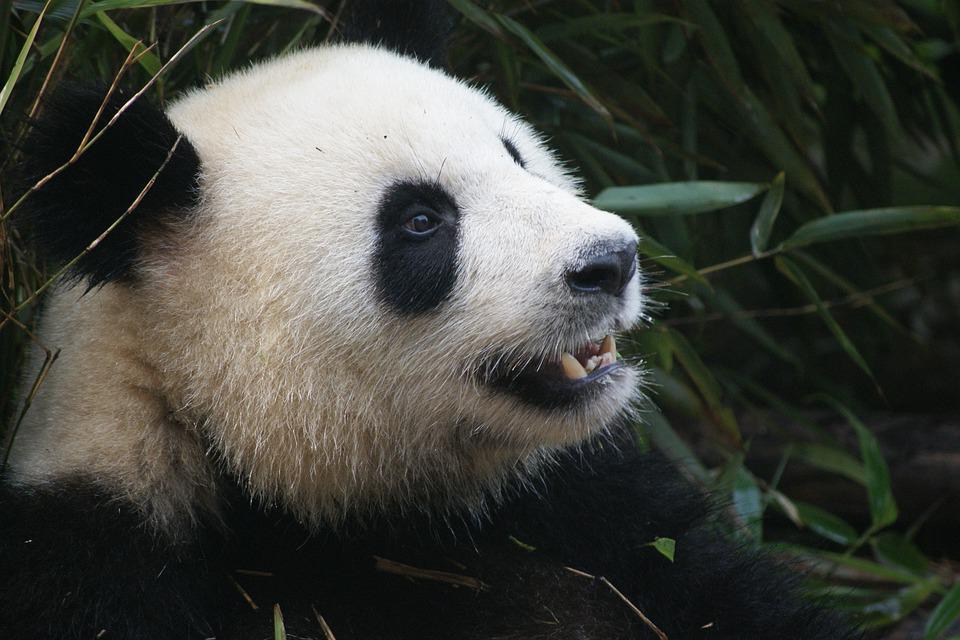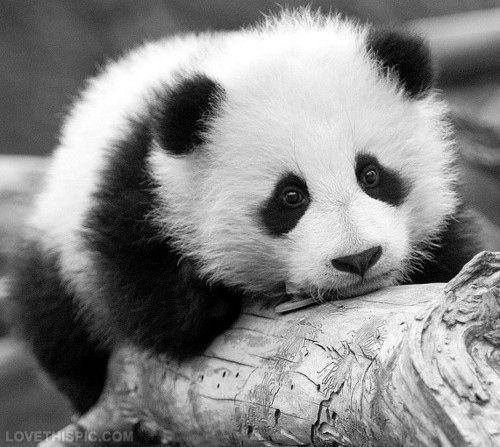The first image is the image on the left, the second image is the image on the right. Given the left and right images, does the statement "The left image contains a panda chewing on food." hold true? Answer yes or no. No. The first image is the image on the left, the second image is the image on the right. Assess this claim about the two images: "An image shows a brown and white panda surrounded by foliage.". Correct or not? Answer yes or no. No. 